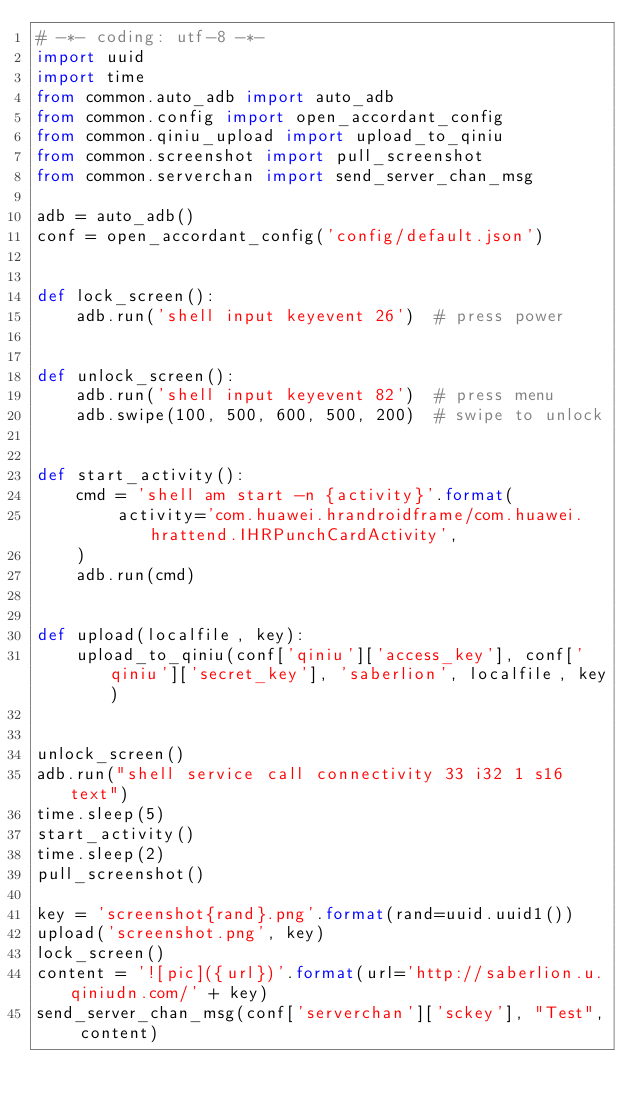Convert code to text. <code><loc_0><loc_0><loc_500><loc_500><_Python_># -*- coding: utf-8 -*-
import uuid
import time
from common.auto_adb import auto_adb
from common.config import open_accordant_config
from common.qiniu_upload import upload_to_qiniu
from common.screenshot import pull_screenshot
from common.serverchan import send_server_chan_msg

adb = auto_adb()
conf = open_accordant_config('config/default.json')


def lock_screen():
    adb.run('shell input keyevent 26')  # press power


def unlock_screen():
    adb.run('shell input keyevent 82')  # press menu
    adb.swipe(100, 500, 600, 500, 200)  # swipe to unlock


def start_activity():
    cmd = 'shell am start -n {activity}'.format(
        activity='com.huawei.hrandroidframe/com.huawei.hrattend.IHRPunchCardActivity',
    )
    adb.run(cmd)


def upload(localfile, key):
    upload_to_qiniu(conf['qiniu']['access_key'], conf['qiniu']['secret_key'], 'saberlion', localfile, key)


unlock_screen()
adb.run("shell service call connectivity 33 i32 1 s16 text")
time.sleep(5)
start_activity()
time.sleep(2)
pull_screenshot()

key = 'screenshot{rand}.png'.format(rand=uuid.uuid1())
upload('screenshot.png', key)
lock_screen()
content = '![pic]({url})'.format(url='http://saberlion.u.qiniudn.com/' + key)
send_server_chan_msg(conf['serverchan']['sckey'], "Test", content)
</code> 